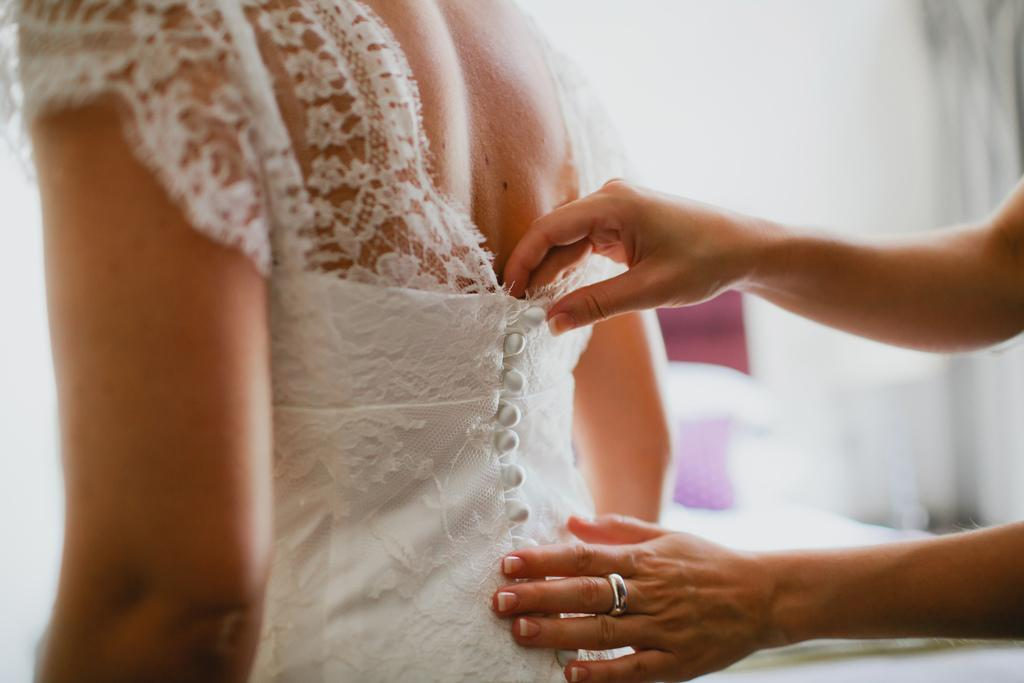What is the lady wearing in the image? The lady is wearing a white gown in the image. What accessory is worn by one of the people in the image? There is a person wearing a silver ring in the image. What action is being performed by the person in the image? The person is touching the lady in the image. How would you describe the background of the image? The background of the image is blurred. How many cats can be seen playing with the silver ring in the image? There are no cats present in the image, and therefore no such activity can be observed. 